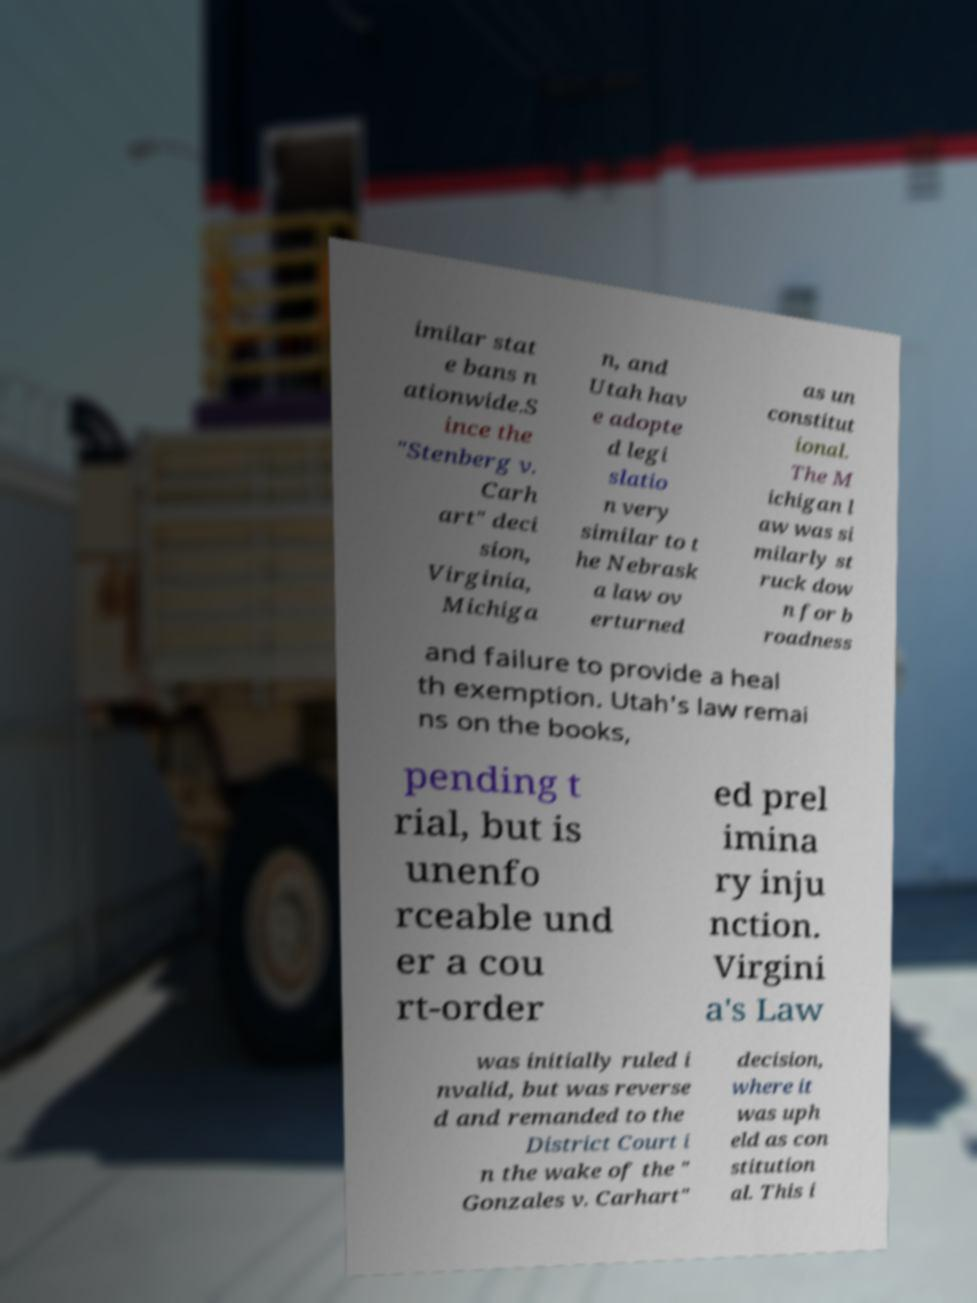What messages or text are displayed in this image? I need them in a readable, typed format. imilar stat e bans n ationwide.S ince the "Stenberg v. Carh art" deci sion, Virginia, Michiga n, and Utah hav e adopte d legi slatio n very similar to t he Nebrask a law ov erturned as un constitut ional. The M ichigan l aw was si milarly st ruck dow n for b roadness and failure to provide a heal th exemption. Utah's law remai ns on the books, pending t rial, but is unenfo rceable und er a cou rt-order ed prel imina ry inju nction. Virgini a's Law was initially ruled i nvalid, but was reverse d and remanded to the District Court i n the wake of the " Gonzales v. Carhart" decision, where it was uph eld as con stitution al. This i 